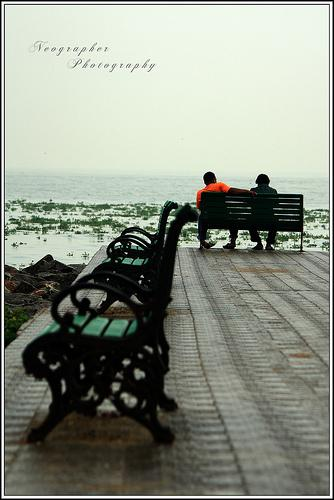Question: where are the people?
Choices:
A. On the sidewalk.
B. On the bench.
C. In the car.
D. On the grass.
Answer with the letter. Answer: B Question: what are the people looking at?
Choices:
A. The ocean.
B. The mountains.
C. The desert.
D. The meadows.
Answer with the letter. Answer: A Question: how many animals are there?
Choices:
A. 7.
B. 8.
C. 9.
D. None.
Answer with the letter. Answer: D Question: who is sitting on the bench?
Choices:
A. Two people.
B. Three people.
C. One person.
D. Four people.
Answer with the letter. Answer: A Question: what time is it?
Choices:
A. Night time.
B. Dusk.
C. Daytime.
D. Dawn.
Answer with the letter. Answer: C 